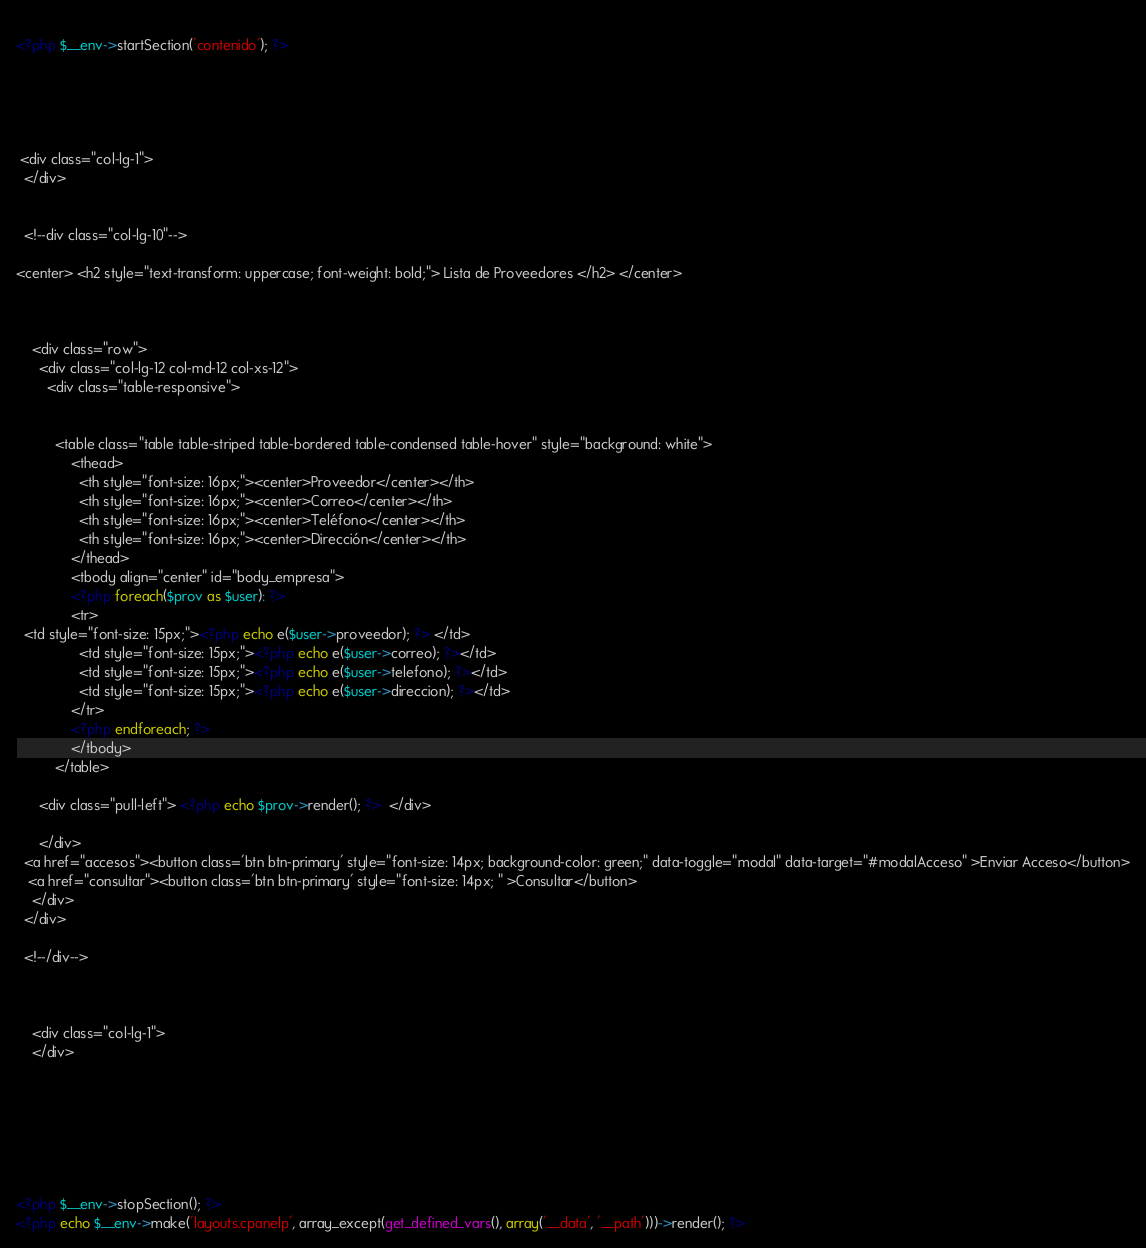Convert code to text. <code><loc_0><loc_0><loc_500><loc_500><_PHP_>  
<?php $__env->startSection('contenido'); ?> 





 <div class="col-lg-1">  
  </div>


  <!--div class="col-lg-10"-->  

<center> <h2 style="text-transform: uppercase; font-weight: bold;"> Lista de Proveedores </h2> </center>
    
    

    <div class="row">
      <div class="col-lg-12 col-md-12 col-xs-12">
        <div class="table-responsive"> 

      
          <table class="table table-striped table-bordered table-condensed table-hover" style="background: white">
              <thead>
                <th style="font-size: 16px;"><center>Proveedor</center></th>
                <th style="font-size: 16px;"><center>Correo</center></th>
                <th style="font-size: 16px;"><center>Teléfono</center></th>
                <th style="font-size: 16px;"><center>Dirección</center></th>
              </thead>
              <tbody align="center" id="body_empresa">          
              <?php foreach($prov as $user): ?>
              <tr>
  <td style="font-size: 15px;"><?php echo e($user->proveedor); ?> </td>          
                <td style="font-size: 15px;"><?php echo e($user->correo); ?></td>
                <td style="font-size: 15px;"><?php echo e($user->telefono); ?></td>
                <td style="font-size: 15px;"><?php echo e($user->direccion); ?></td>
              </tr>
              <?php endforeach; ?>
              </tbody>          
          </table>

      <div class="pull-left"> <?php echo $prov->render(); ?>  </div>

      </div>
  <a href="accesos"><button class='btn btn-primary' style="font-size: 14px; background-color: green;" data-toggle="modal" data-target="#modalAcceso" >Enviar Acceso</button>
   <a href="consultar"><button class='btn btn-primary' style="font-size: 14px; " >Consultar</button>
    </div>
  </div>

  <!--/div-->



    <div class="col-lg-1">  
    </div>


      




<?php $__env->stopSection(); ?>
<?php echo $__env->make('layouts.cpanelp', array_except(get_defined_vars(), array('__data', '__path')))->render(); ?></code> 